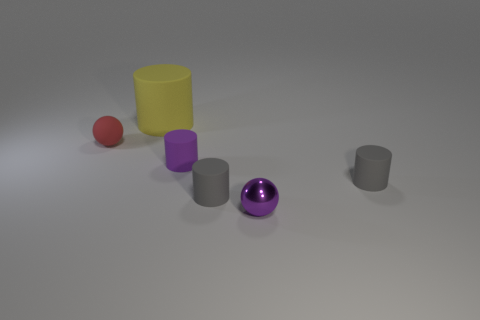What material is the thing that is both in front of the big rubber object and behind the small purple rubber object?
Offer a terse response. Rubber. There is a object that is both left of the small purple matte object and in front of the big object; what color is it?
Your answer should be very brief. Red. Is there any other thing that has the same color as the metal thing?
Offer a terse response. Yes. The purple object to the left of the ball that is to the right of the small matte thing that is left of the purple matte object is what shape?
Keep it short and to the point. Cylinder. There is another small shiny object that is the same shape as the red thing; what color is it?
Provide a succinct answer. Purple. What is the color of the small ball that is to the right of the tiny purple thing behind the shiny thing?
Offer a terse response. Purple. What size is the purple object that is the same shape as the yellow thing?
Provide a succinct answer. Small. How many small purple objects have the same material as the yellow cylinder?
Provide a short and direct response. 1. There is a object that is left of the yellow rubber object; how many rubber things are in front of it?
Provide a short and direct response. 3. Are there any small red rubber spheres to the left of the yellow matte cylinder?
Your answer should be compact. Yes. 